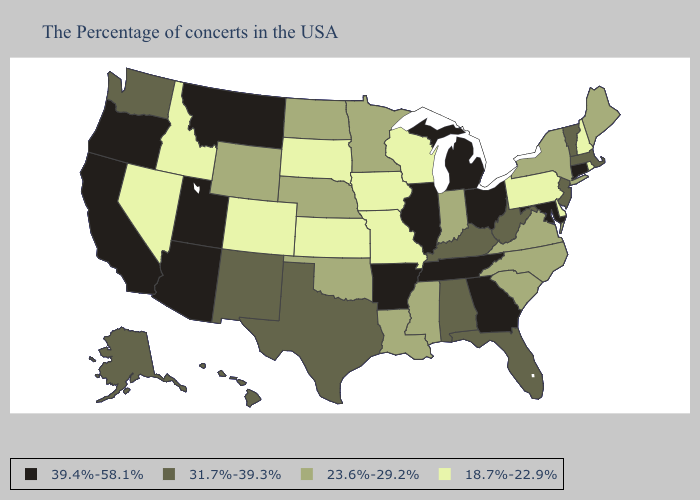What is the lowest value in states that border New Jersey?
Short answer required. 18.7%-22.9%. Does Maine have the highest value in the USA?
Short answer required. No. What is the highest value in states that border North Dakota?
Answer briefly. 39.4%-58.1%. Which states have the lowest value in the West?
Keep it brief. Colorado, Idaho, Nevada. What is the lowest value in the MidWest?
Short answer required. 18.7%-22.9%. Name the states that have a value in the range 39.4%-58.1%?
Concise answer only. Connecticut, Maryland, Ohio, Georgia, Michigan, Tennessee, Illinois, Arkansas, Utah, Montana, Arizona, California, Oregon. Among the states that border South Dakota , does Montana have the highest value?
Concise answer only. Yes. Among the states that border Vermont , does Massachusetts have the highest value?
Quick response, please. Yes. Is the legend a continuous bar?
Short answer required. No. Does Delaware have the lowest value in the South?
Quick response, please. Yes. Does Delaware have the highest value in the USA?
Concise answer only. No. Which states have the lowest value in the MidWest?
Quick response, please. Wisconsin, Missouri, Iowa, Kansas, South Dakota. Does New Hampshire have the lowest value in the USA?
Quick response, please. Yes. Among the states that border Wyoming , which have the highest value?
Short answer required. Utah, Montana. What is the value of New Jersey?
Concise answer only. 31.7%-39.3%. 